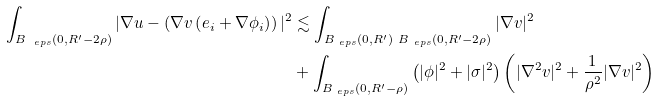<formula> <loc_0><loc_0><loc_500><loc_500>\int _ { B _ { \ e p s } ( 0 , R ^ { \prime } - 2 \rho ) } | \nabla u - \left ( \nabla v \left ( e _ { i } + \nabla \phi _ { i } \right ) \right ) | ^ { 2 } & \lesssim \int _ { B _ { \ e p s } ( 0 , R ^ { \prime } ) \ B _ { \ e p s } ( 0 , R ^ { \prime } - 2 \rho ) } | \nabla v | ^ { 2 } \\ & + \int _ { B _ { \ e p s } ( 0 , R ^ { \prime } - \rho ) } \left ( | \phi | ^ { 2 } + | \sigma | ^ { 2 } \right ) \left ( | \nabla ^ { 2 } v | ^ { 2 } + \frac { 1 } { \rho ^ { 2 } } | \nabla v | ^ { 2 } \right ) \\</formula> 